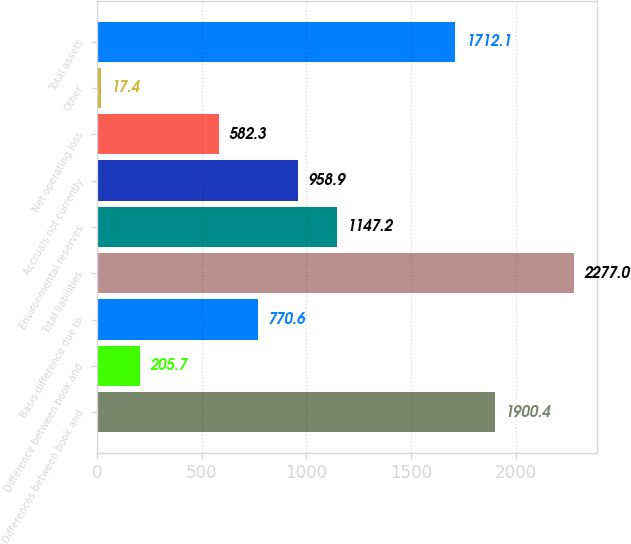Convert chart. <chart><loc_0><loc_0><loc_500><loc_500><bar_chart><fcel>Differences between book and<fcel>Difference between book and<fcel>Basis difference due to<fcel>Total liabilities<fcel>Environmental reserves<fcel>Accruals not currently<fcel>Net operating loss<fcel>Other<fcel>Total assets<nl><fcel>1900.4<fcel>205.7<fcel>770.6<fcel>2277<fcel>1147.2<fcel>958.9<fcel>582.3<fcel>17.4<fcel>1712.1<nl></chart> 